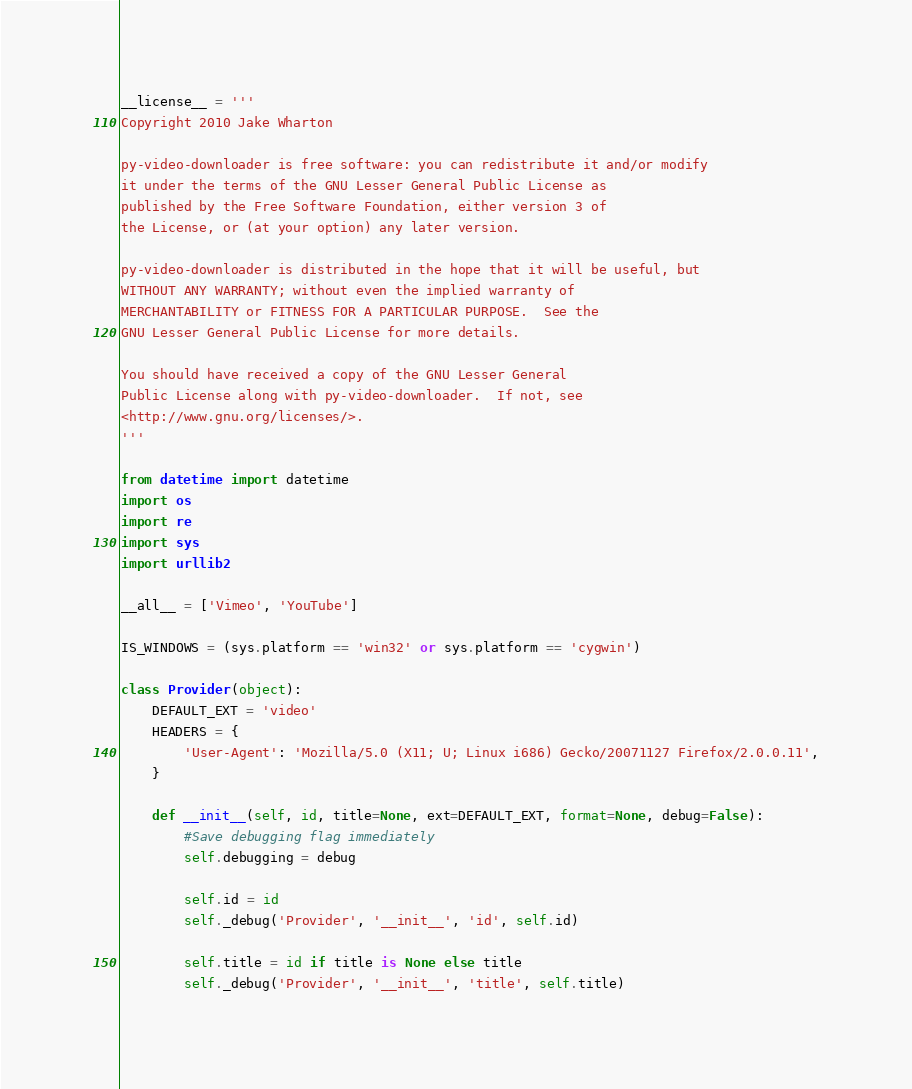Convert code to text. <code><loc_0><loc_0><loc_500><loc_500><_Python_>__license__ = '''
Copyright 2010 Jake Wharton

py-video-downloader is free software: you can redistribute it and/or modify
it under the terms of the GNU Lesser General Public License as
published by the Free Software Foundation, either version 3 of
the License, or (at your option) any later version.

py-video-downloader is distributed in the hope that it will be useful, but
WITHOUT ANY WARRANTY; without even the implied warranty of
MERCHANTABILITY or FITNESS FOR A PARTICULAR PURPOSE.  See the
GNU Lesser General Public License for more details.

You should have received a copy of the GNU Lesser General
Public License along with py-video-downloader.  If not, see
<http://www.gnu.org/licenses/>.
'''

from datetime import datetime
import os
import re
import sys
import urllib2

__all__ = ['Vimeo', 'YouTube']

IS_WINDOWS = (sys.platform == 'win32' or sys.platform == 'cygwin')

class Provider(object):
    DEFAULT_EXT = 'video'
    HEADERS = {
        'User-Agent': 'Mozilla/5.0 (X11; U; Linux i686) Gecko/20071127 Firefox/2.0.0.11',
    }

    def __init__(self, id, title=None, ext=DEFAULT_EXT, format=None, debug=False):
        #Save debugging flag immediately
        self.debugging = debug

        self.id = id
        self._debug('Provider', '__init__', 'id', self.id)

        self.title = id if title is None else title
        self._debug('Provider', '__init__', 'title', self.title)
</code> 